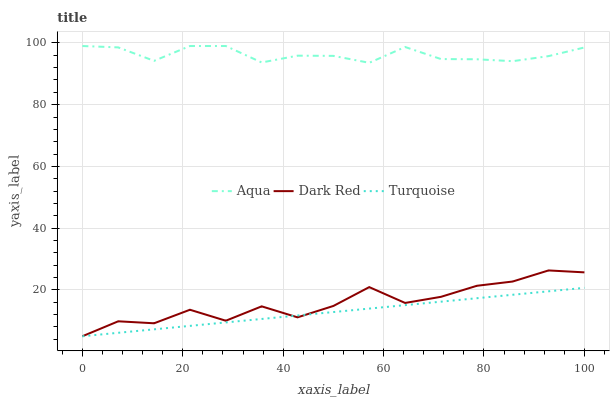Does Aqua have the minimum area under the curve?
Answer yes or no. No. Does Turquoise have the maximum area under the curve?
Answer yes or no. No. Is Aqua the smoothest?
Answer yes or no. No. Is Aqua the roughest?
Answer yes or no. No. Does Aqua have the lowest value?
Answer yes or no. No. Does Turquoise have the highest value?
Answer yes or no. No. Is Dark Red less than Aqua?
Answer yes or no. Yes. Is Aqua greater than Dark Red?
Answer yes or no. Yes. Does Dark Red intersect Aqua?
Answer yes or no. No. 